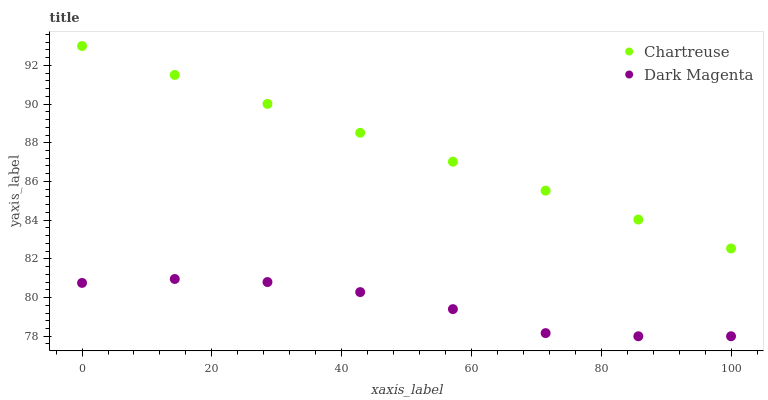Does Dark Magenta have the minimum area under the curve?
Answer yes or no. Yes. Does Chartreuse have the maximum area under the curve?
Answer yes or no. Yes. Does Dark Magenta have the maximum area under the curve?
Answer yes or no. No. Is Chartreuse the smoothest?
Answer yes or no. Yes. Is Dark Magenta the roughest?
Answer yes or no. Yes. Is Dark Magenta the smoothest?
Answer yes or no. No. Does Dark Magenta have the lowest value?
Answer yes or no. Yes. Does Chartreuse have the highest value?
Answer yes or no. Yes. Does Dark Magenta have the highest value?
Answer yes or no. No. Is Dark Magenta less than Chartreuse?
Answer yes or no. Yes. Is Chartreuse greater than Dark Magenta?
Answer yes or no. Yes. Does Dark Magenta intersect Chartreuse?
Answer yes or no. No. 